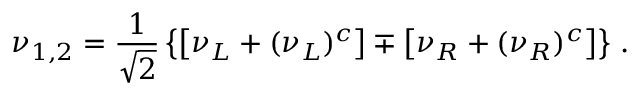Convert formula to latex. <formula><loc_0><loc_0><loc_500><loc_500>\nu _ { 1 , 2 } = \frac { 1 } { \sqrt { 2 } } \left \{ \left [ \nu _ { L } + ( \nu _ { L } ) ^ { c } \right ] \mp \left [ \nu _ { R } + ( \nu _ { R } ) ^ { c } \right ] \right \} \, .</formula> 